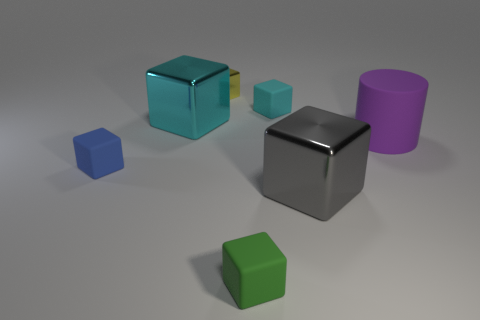What could be the sizes of these objects relative to each other? Relative to each other, the image shows a variety of sizes: the silver and green cubes seem medium-sized, with the silver cube slightly larger; the blue cubes are small; and the purple cylinder is tall, suggesting it is the largest object. 